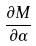<formula> <loc_0><loc_0><loc_500><loc_500>\frac { \partial M } { \partial \alpha }</formula> 